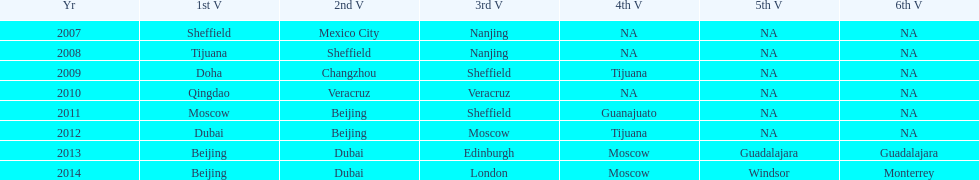Name a year whose second venue was the same as 2011. 2012. 